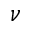<formula> <loc_0><loc_0><loc_500><loc_500>\nu</formula> 